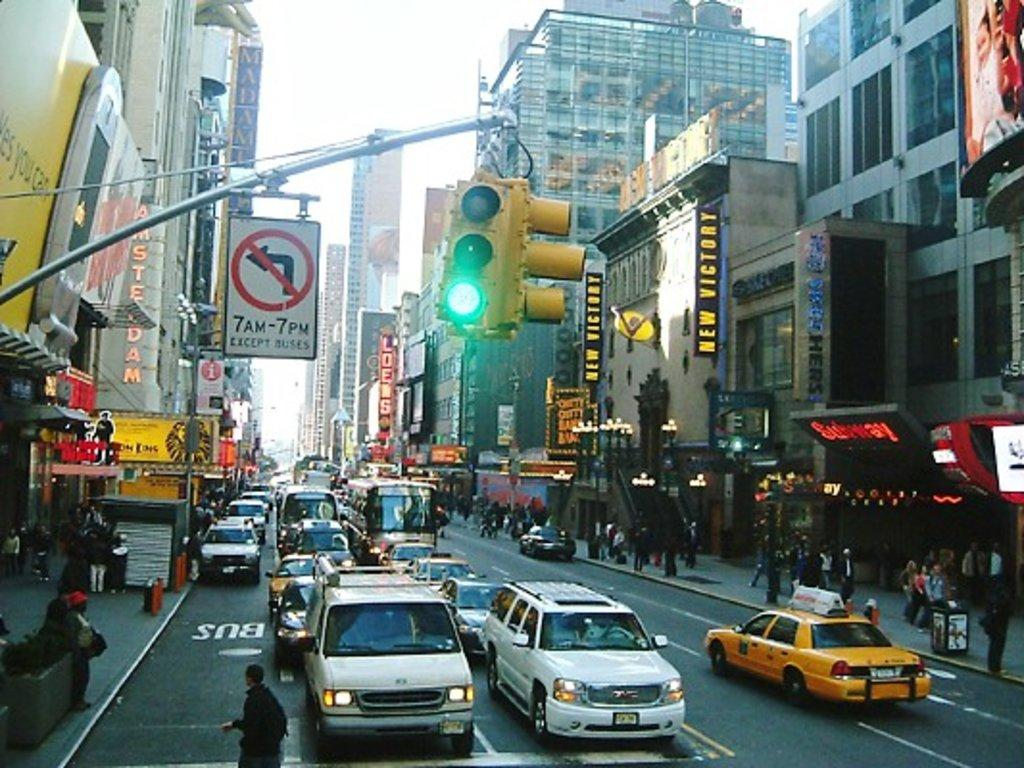<image>
Share a concise interpretation of the image provided. A busy street with many cars and people and a no left turn sign from 7 AM-7 PM. 